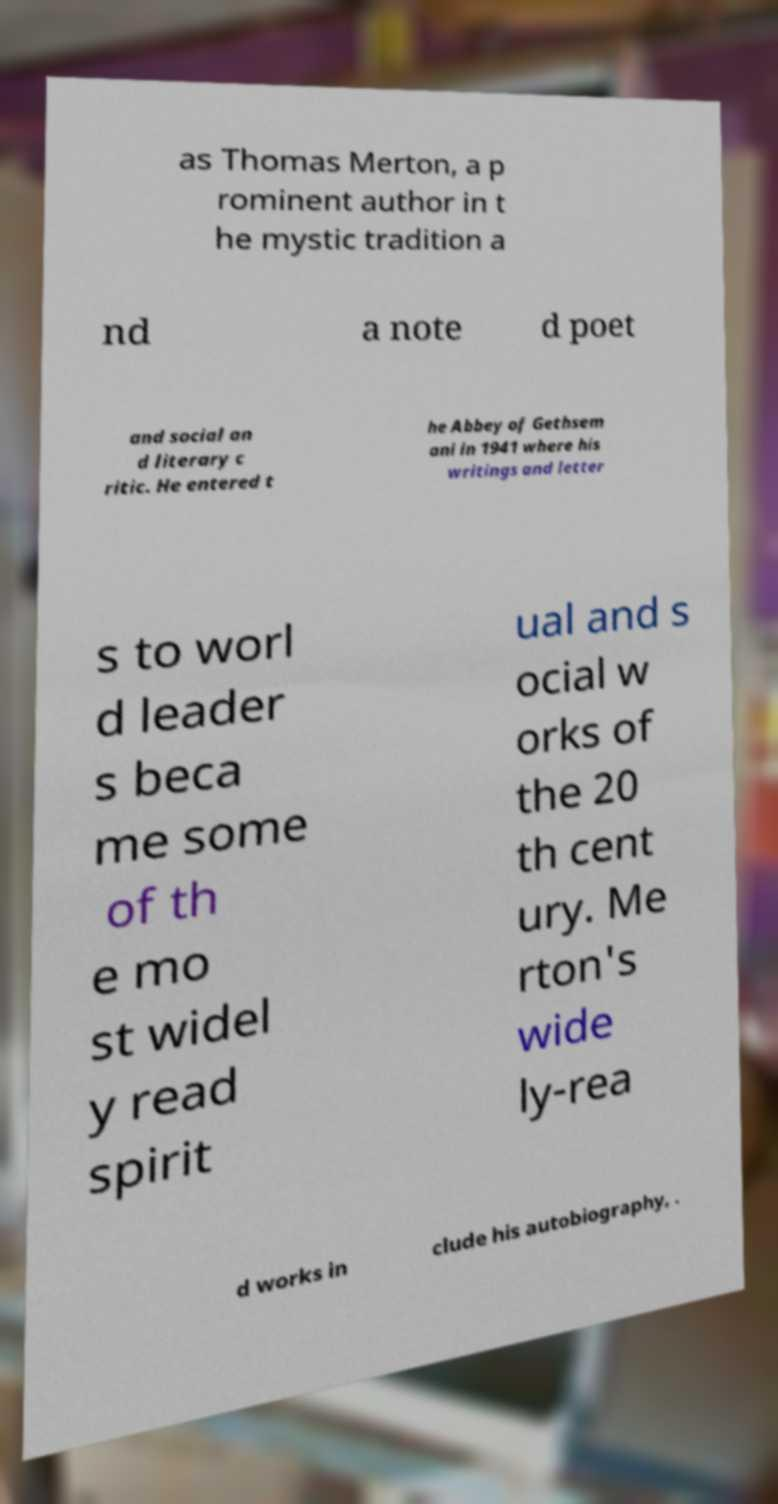I need the written content from this picture converted into text. Can you do that? as Thomas Merton, a p rominent author in t he mystic tradition a nd a note d poet and social an d literary c ritic. He entered t he Abbey of Gethsem ani in 1941 where his writings and letter s to worl d leader s beca me some of th e mo st widel y read spirit ual and s ocial w orks of the 20 th cent ury. Me rton's wide ly-rea d works in clude his autobiography, . 